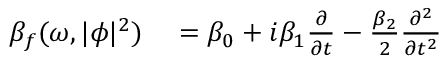<formula> <loc_0><loc_0><loc_500><loc_500>\begin{array} { r l } { \beta _ { f } ( \omega , | \phi | ^ { 2 } ) } & = \beta _ { 0 } + i \beta _ { 1 } \frac { \partial } { \partial t } - \frac { \beta _ { 2 } } { 2 } \frac { \partial ^ { 2 } } { \partial t ^ { 2 } } } \end{array}</formula> 